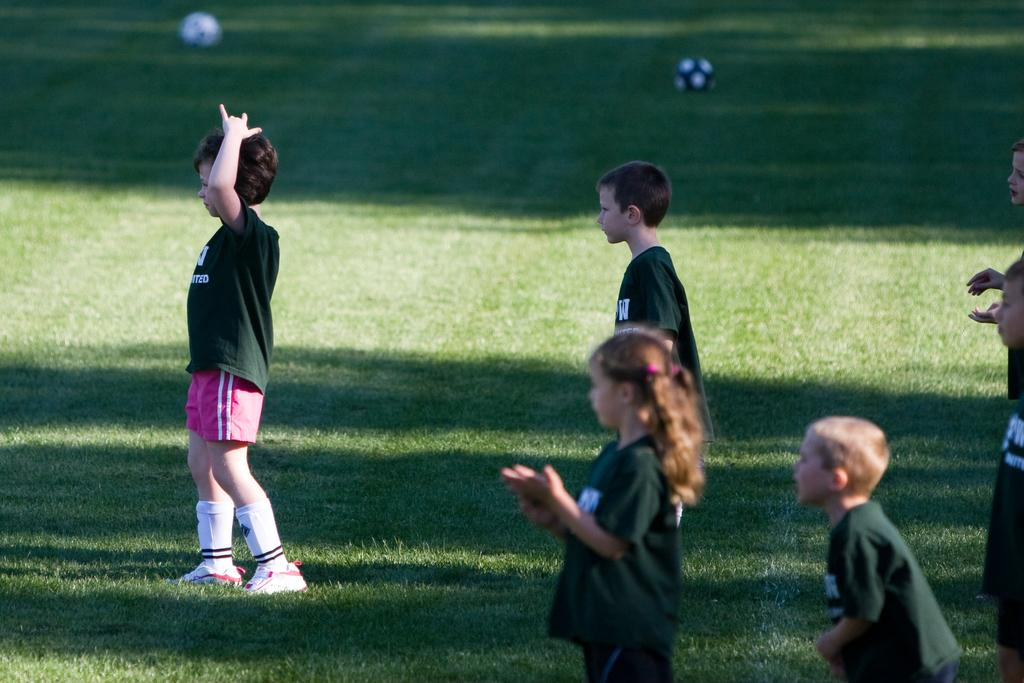Where was the picture taken? The picture was clicked outside. What is the main subject of the image? There is a group of children in the center of the image. What are the children wearing? The children are wearing green color t-shirts. What can be seen in the background of the image? There is green grass visible in the image. What objects are lying on the ground in the image? There are balls lying on the ground in the image. Can you hear the whistle of the volcano in the image? There is no volcano or whistle present in the image; it features a group of children wearing green t-shirts and playing with balls on green grass. 